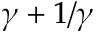<formula> <loc_0><loc_0><loc_500><loc_500>\gamma + 1 / \gamma</formula> 